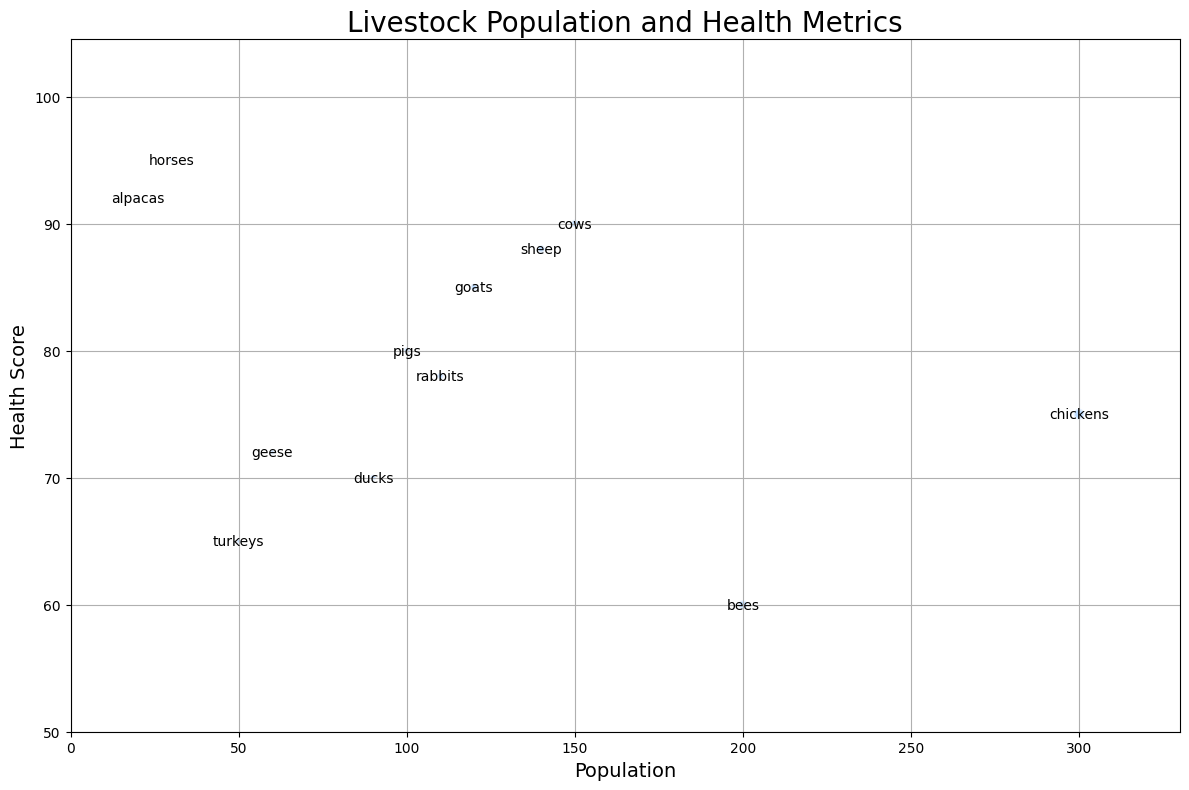Which livestock type has the highest health score? The figure displays each livestock type along with its health score. The livestock type with the highest health score is represented by the highest bubble along the y-axis, which is "horses" with a health score of 95.
Answer: horses Which livestock type has the largest population? The figure shows the population sizes of different livestock types on the x-axis. The livestock type with the largest bubble, indicating the largest population, is "chickens" with a population of 300.
Answer: chickens Find the difference in health scores between the livestock types with the highest and lowest populations. From the figure, "chickens" have the highest population (300), and "alpacas" have the lowest population (20). Their health scores are 75 and 92, respectively. The difference is calculated as 92 - 75.
Answer: 17 Which livestock type has a higher health score: cows or pigs? Observing the positions of the bubbles labeled "cows" and "pigs," "cows" have a health score of 90 while "pigs" have a health score of 80. Therefore, "cows" have a higher health score.
Answer: cows What is the average health score of all labeled livestock? To find the average, sum all the health scores (85 + 90 + 88 + 75 + 80 + 70 + 65 + 78 + 95 + 72 + 92 + 60) which equals 950. There are 12 livestock types, so the average health score is 950 / 12.
Answer: 79.17 Which livestock type has the smallest bubble? The size of the bubble is proportional to the population. The smallest bubble in the figure corresponds to the livestock type "alpacas" with a population of 20.
Answer: alpacas Which are healthier on average: livestock with populations above 100 or below 100? Grouping livestock by populations > 100 (goats, cows, sheep, chickens, bees) and < 100 (pigs, ducks, turkeys, rabbits, horses, geese, alpacas), calculate the average health scores. Above 100: (85 + 90 + 88 + 75 + 60) / 5 = 79.6. Below 100: (80 + 70 + 65 + 78 + 95 + 72 + 92) / 7 = 78.29.
Answer: Above 100 Which pair of livestock types have the closest health scores? Comparing the health scores in the figure, the closest values are between "ducks" (70) and "geese" (72), with a difference of 2.
Answer: ducks and geese 